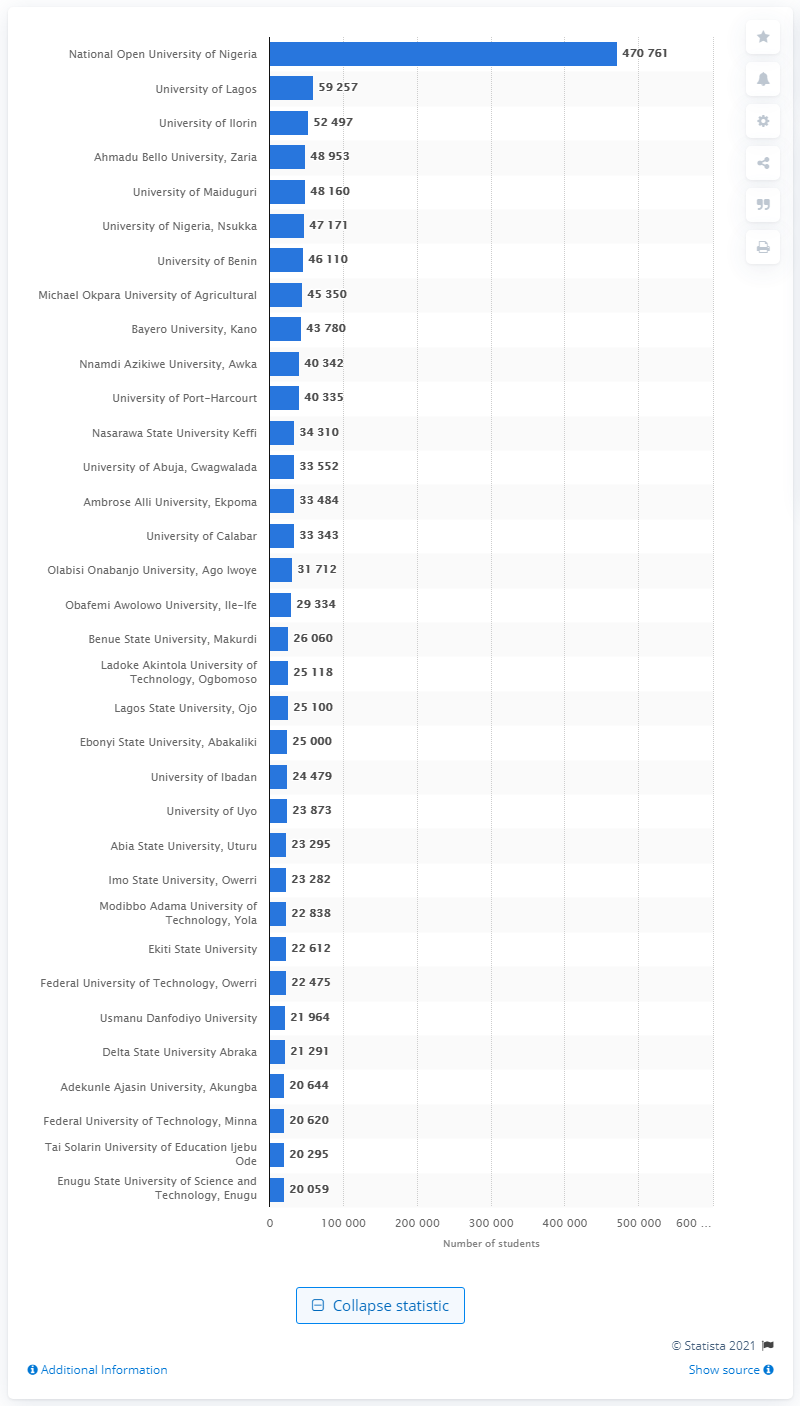Identify some key points in this picture. In 2017, a total of 470,761 undergraduate and postgraduate students attended the National Open University of Nigeria. In 2017, the National Open University of Nigeria was the largest university in terms of the number of students enrolled, with a significant number of students studying across its various programmes and study centres nationwide. 